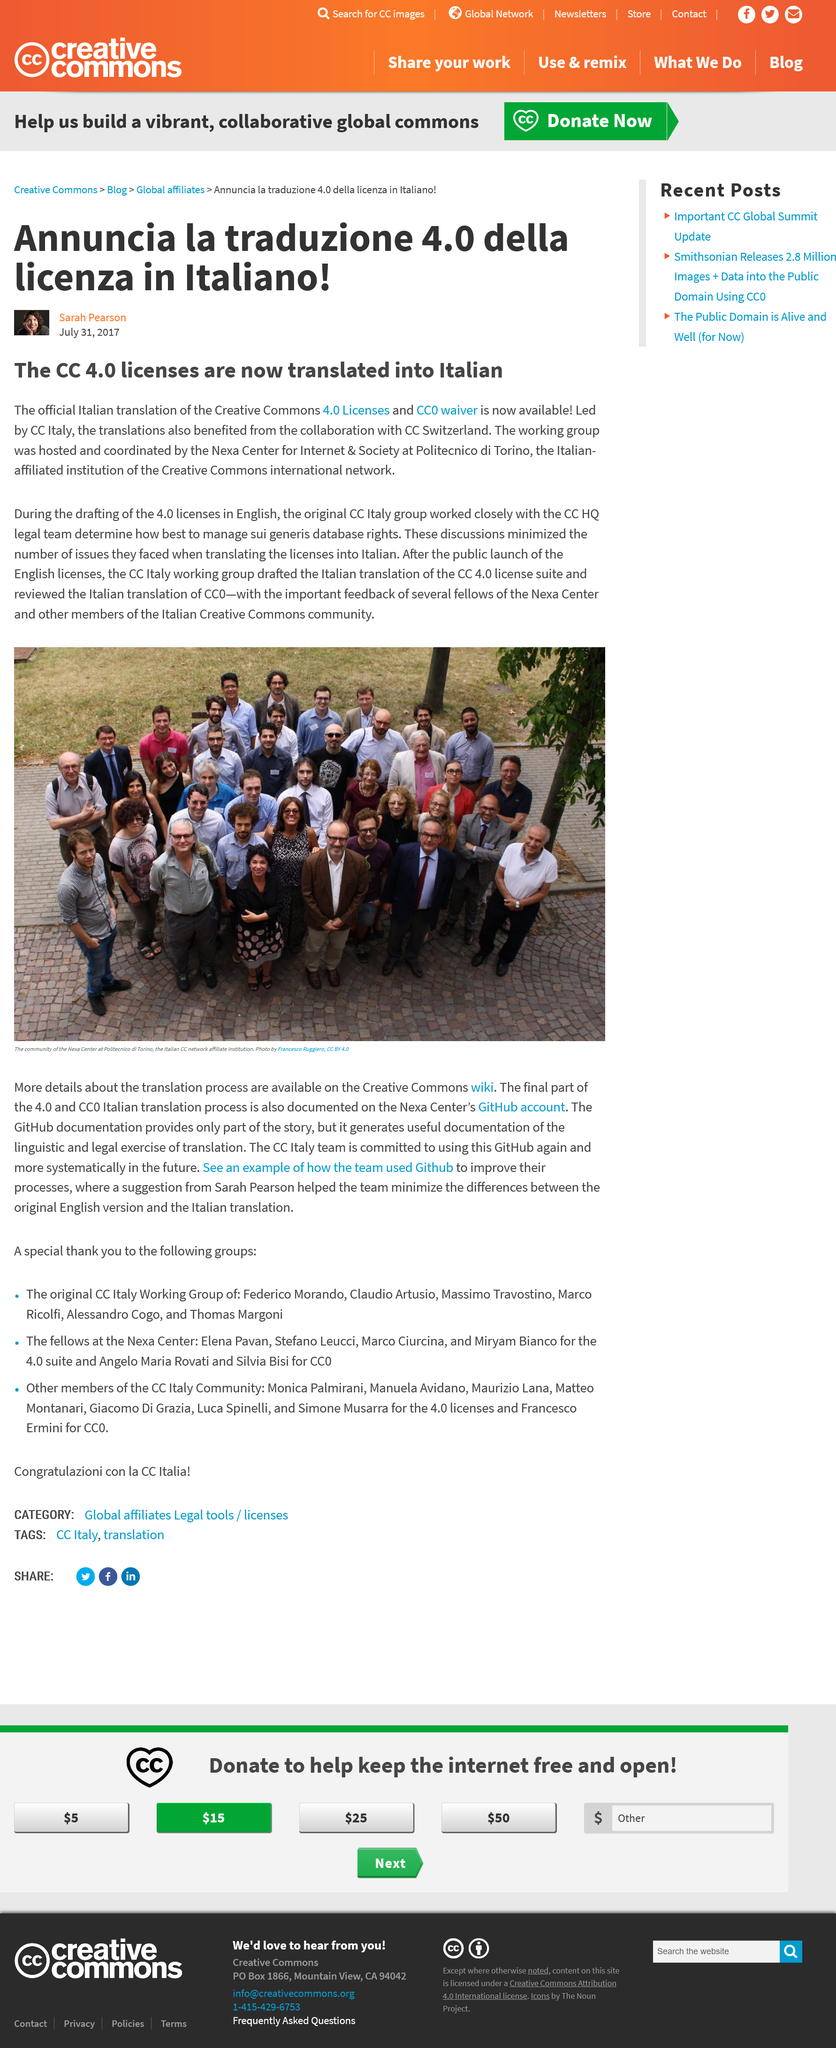Outline some significant characteristics in this image. The CC Italy group collaborated closely with the CC Switzerland group on the Italian translation project. The CC Italy translation group was hosted by the Nexa Center for Internet and Society. The Creative Commons CC 4.0 licenses and CC0 waiver were translated into Italian for the versions of the CC. 